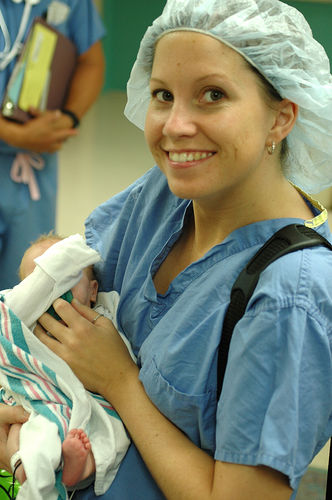What is the overall image quality?
A. Average
B. Excellent
C. Good
D. Poor
Answer with the option's letter from the given choices directly. The overall image quality can be classified as good. While it might not meet the standards of 'excellent', due to potential factors like the lighting conditions or the resolution, it clearly surpasses what would be considered 'average' or 'poor'. The subjects are well-focused, and the emotions are clearly conveyed, contributing positively to the quality of the image. 